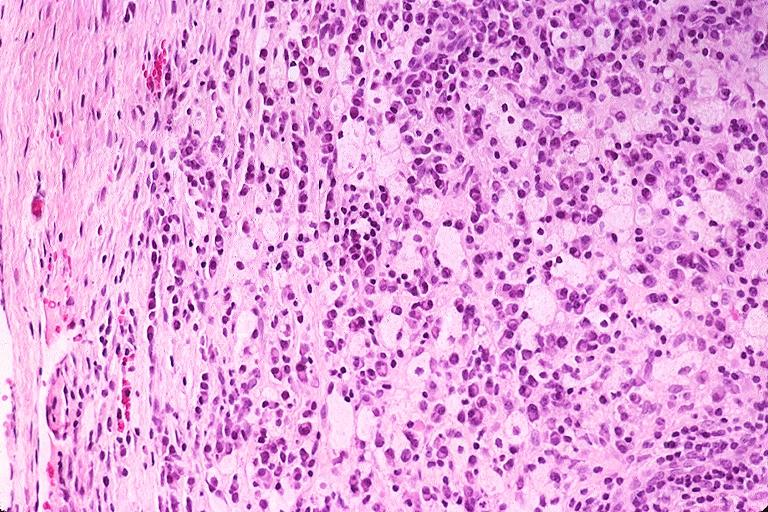s cut present?
Answer the question using a single word or phrase. No 